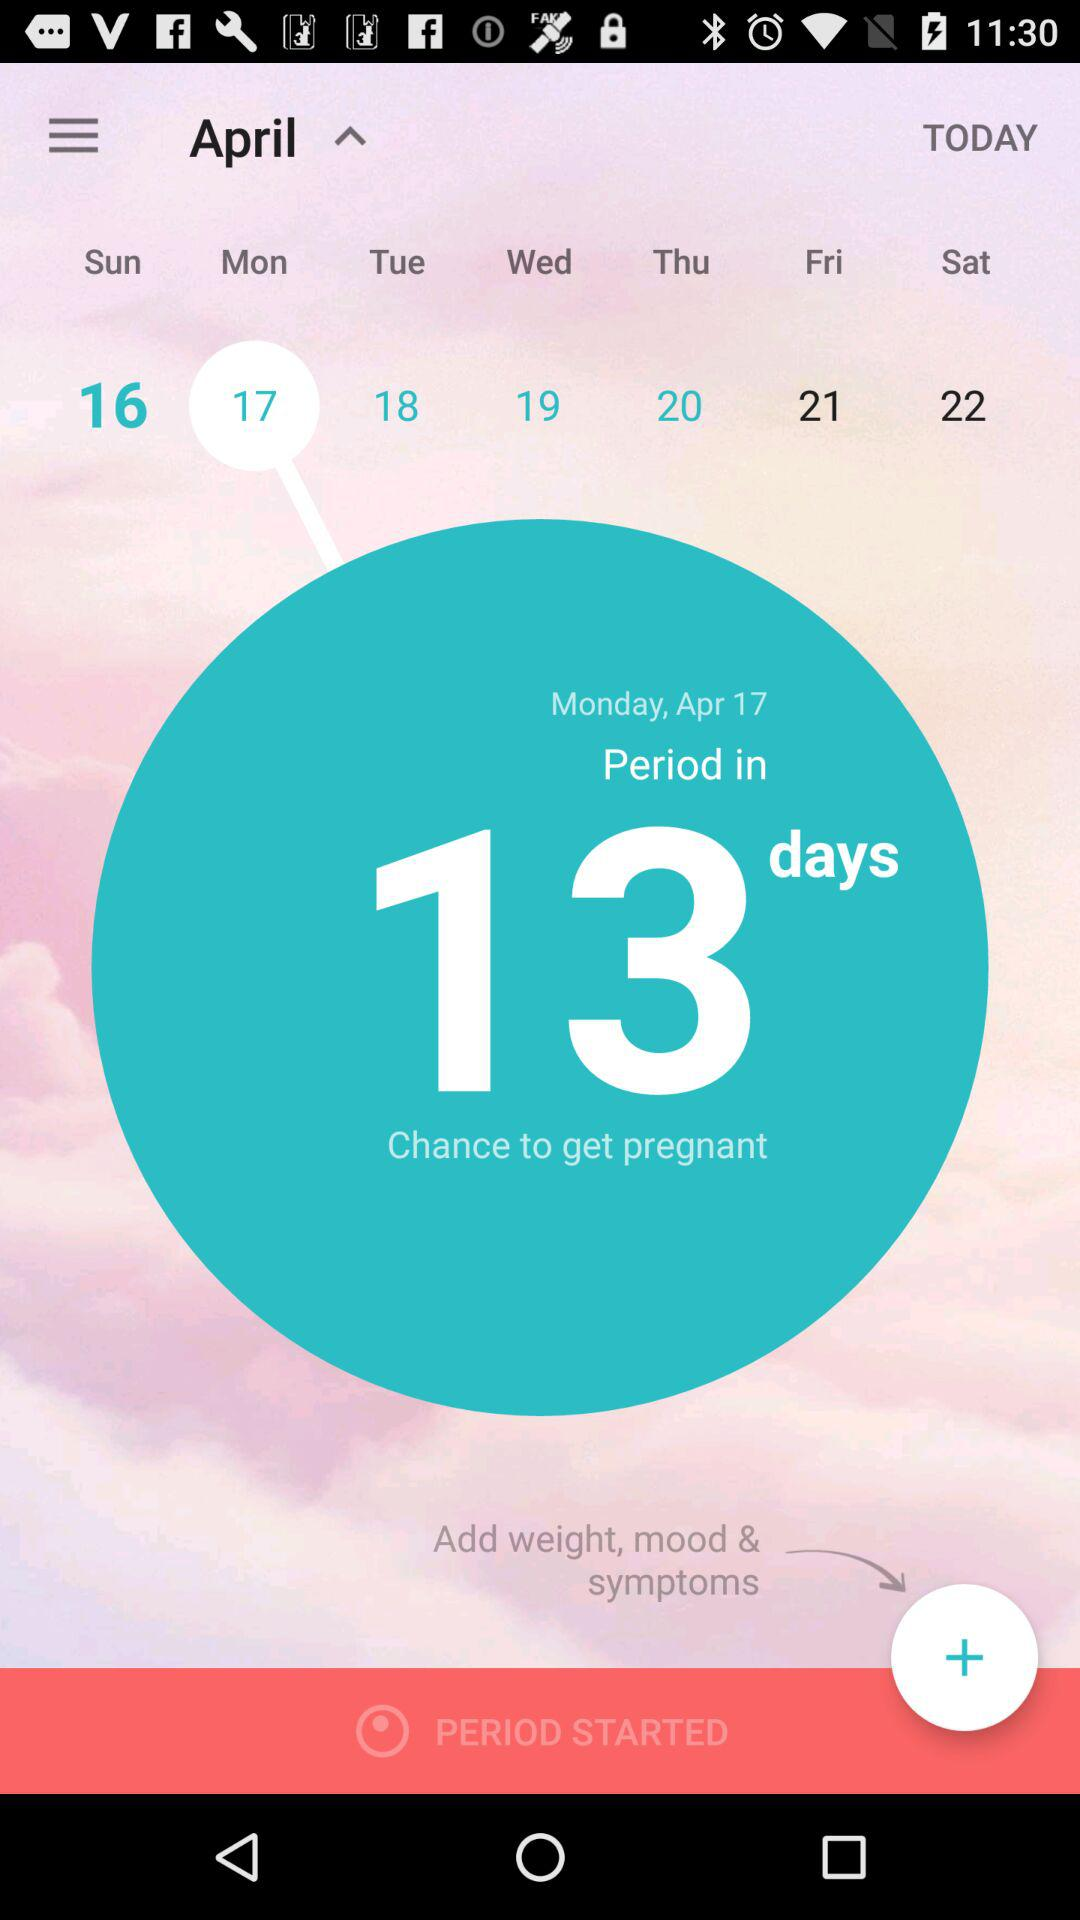In how many days would you have a chance of getting pregnant? You would have a chance of getting pregnant in 13 days. 